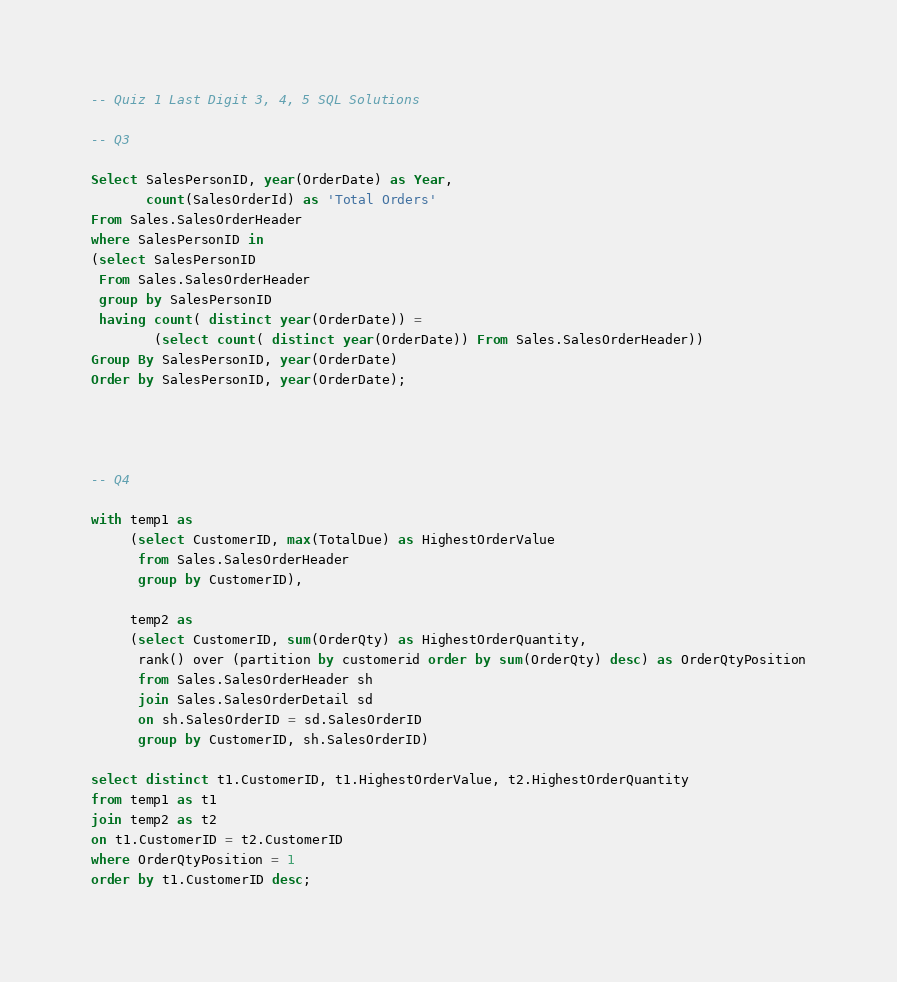Convert code to text. <code><loc_0><loc_0><loc_500><loc_500><_SQL_>
-- Quiz 1 Last Digit 3, 4, 5 SQL Solutions

-- Q3

Select SalesPersonID, year(OrderDate) as Year,
       count(SalesOrderId) as 'Total Orders'
From Sales.SalesOrderHeader
where SalesPersonID in
(select SalesPersonID
 From Sales.SalesOrderHeader
 group by SalesPersonID
 having count( distinct year(OrderDate)) = 
        (select count( distinct year(OrderDate)) From Sales.SalesOrderHeader))
Group By SalesPersonID, year(OrderDate)
Order by SalesPersonID, year(OrderDate);




-- Q4

with temp1 as
     (select CustomerID, max(TotalDue) as HighestOrderValue
      from Sales.SalesOrderHeader
      group by CustomerID),

     temp2 as
	 (select CustomerID, sum(OrderQty) as HighestOrderQuantity,
      rank() over (partition by customerid order by sum(OrderQty) desc) as OrderQtyPosition
      from Sales.SalesOrderHeader sh
      join Sales.SalesOrderDetail sd
      on sh.SalesOrderID = sd.SalesOrderID
      group by CustomerID, sh.SalesOrderID)

select distinct t1.CustomerID, t1.HighestOrderValue, t2.HighestOrderQuantity
from temp1 as t1
join temp2 as t2
on t1.CustomerID = t2.CustomerID
where OrderQtyPosition = 1
order by t1.CustomerID desc;



</code> 